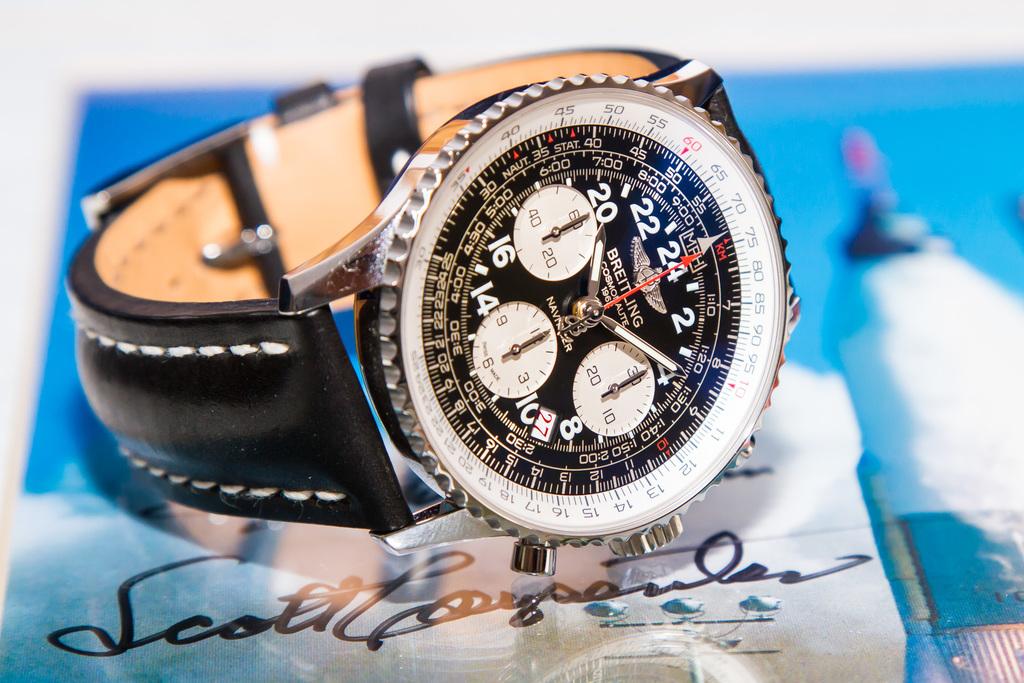What time is the watch pointing to?
Give a very brief answer. 10:12. What number does the red seconds hand point too?
Keep it short and to the point. 24. 